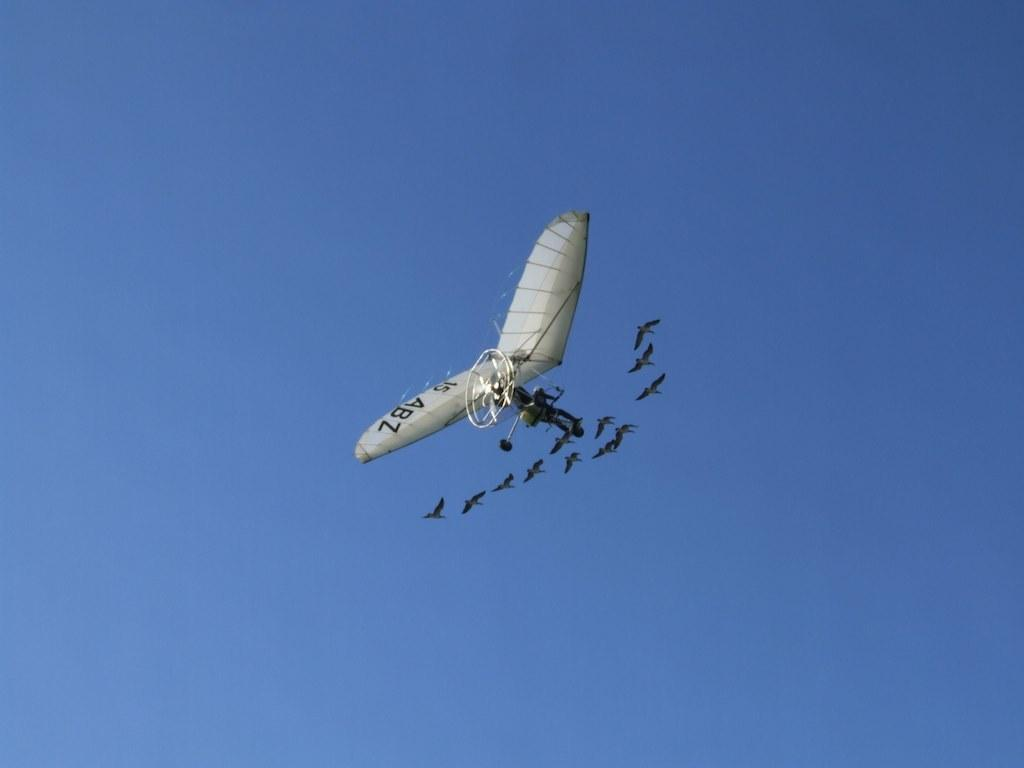<image>
Give a short and clear explanation of the subsequent image. A person flies in a powered paraglider with 15 ABZ written on its wing. 